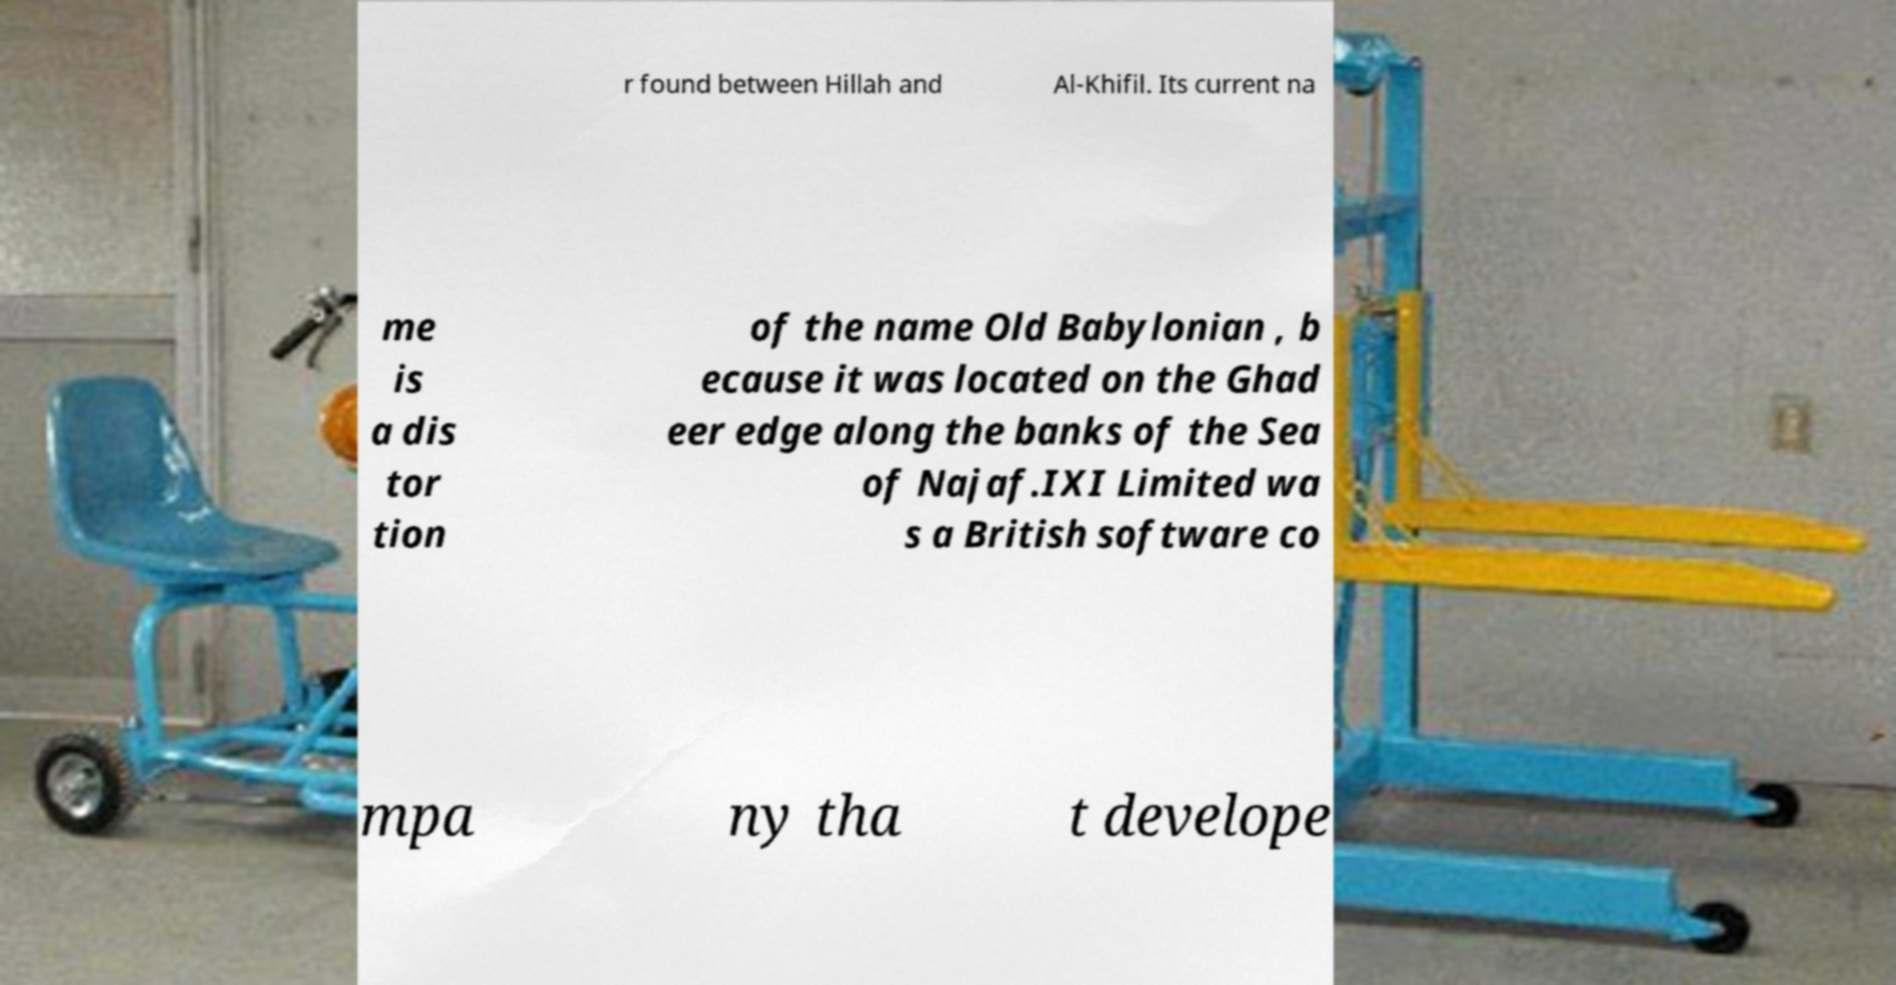For documentation purposes, I need the text within this image transcribed. Could you provide that? r found between Hillah and Al-Khifil. Its current na me is a dis tor tion of the name Old Babylonian , b ecause it was located on the Ghad eer edge along the banks of the Sea of Najaf.IXI Limited wa s a British software co mpa ny tha t develope 